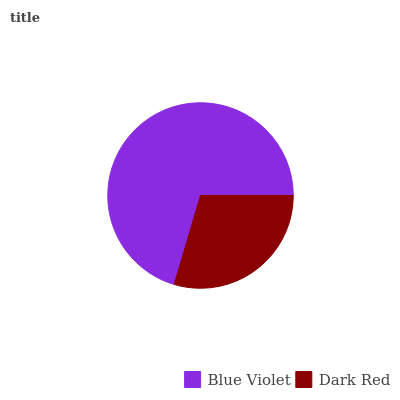Is Dark Red the minimum?
Answer yes or no. Yes. Is Blue Violet the maximum?
Answer yes or no. Yes. Is Dark Red the maximum?
Answer yes or no. No. Is Blue Violet greater than Dark Red?
Answer yes or no. Yes. Is Dark Red less than Blue Violet?
Answer yes or no. Yes. Is Dark Red greater than Blue Violet?
Answer yes or no. No. Is Blue Violet less than Dark Red?
Answer yes or no. No. Is Blue Violet the high median?
Answer yes or no. Yes. Is Dark Red the low median?
Answer yes or no. Yes. Is Dark Red the high median?
Answer yes or no. No. Is Blue Violet the low median?
Answer yes or no. No. 